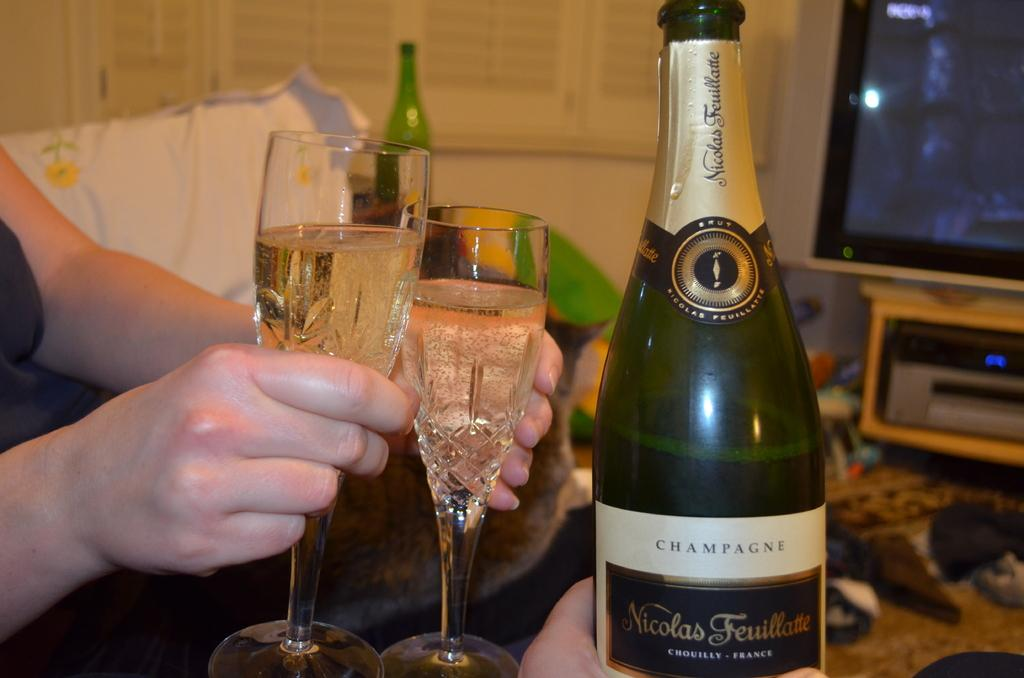<image>
Give a short and clear explanation of the subsequent image. A bottle of Nicolas Feuillatte is displayed with someone holding two glasses of liquor. 